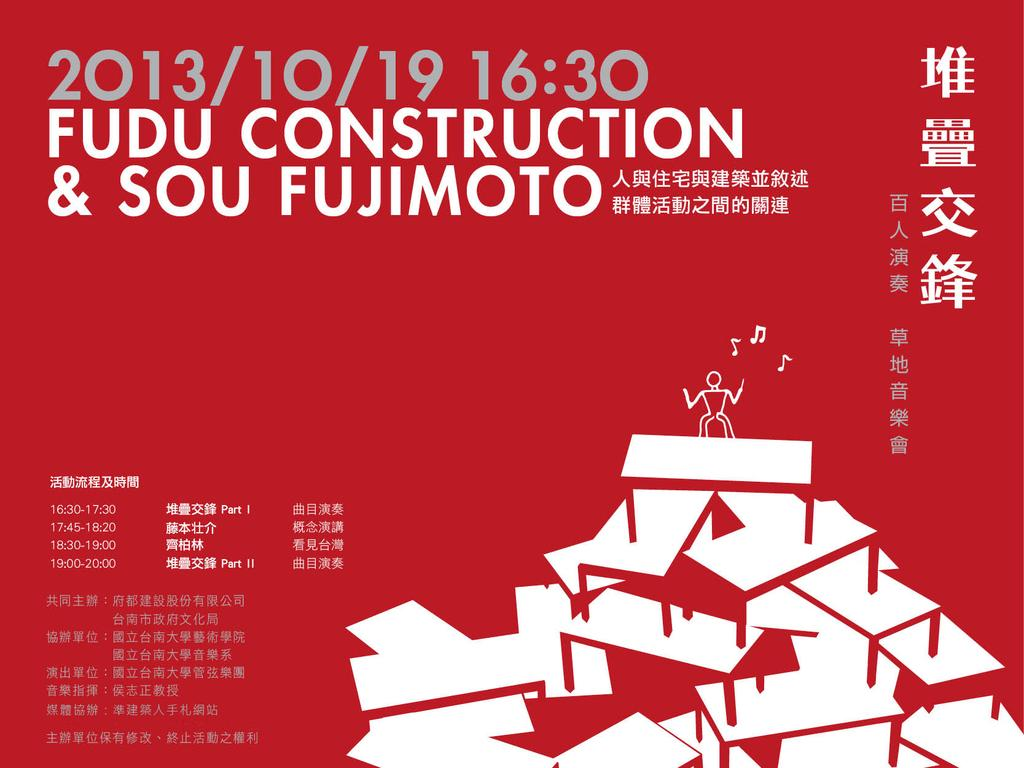<image>
Render a clear and concise summary of the photo. Fudu Construction is advertising for a 2013/10/10 event. 